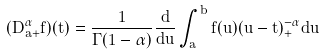<formula> <loc_0><loc_0><loc_500><loc_500>( D ^ { \alpha } _ { a + } f ) ( t ) = \frac { 1 } { \Gamma ( 1 - \alpha ) } \frac { d } { d u } \int ^ { b } _ { a } f ( u ) ( u - t ) ^ { - \alpha } _ { + } d u</formula> 